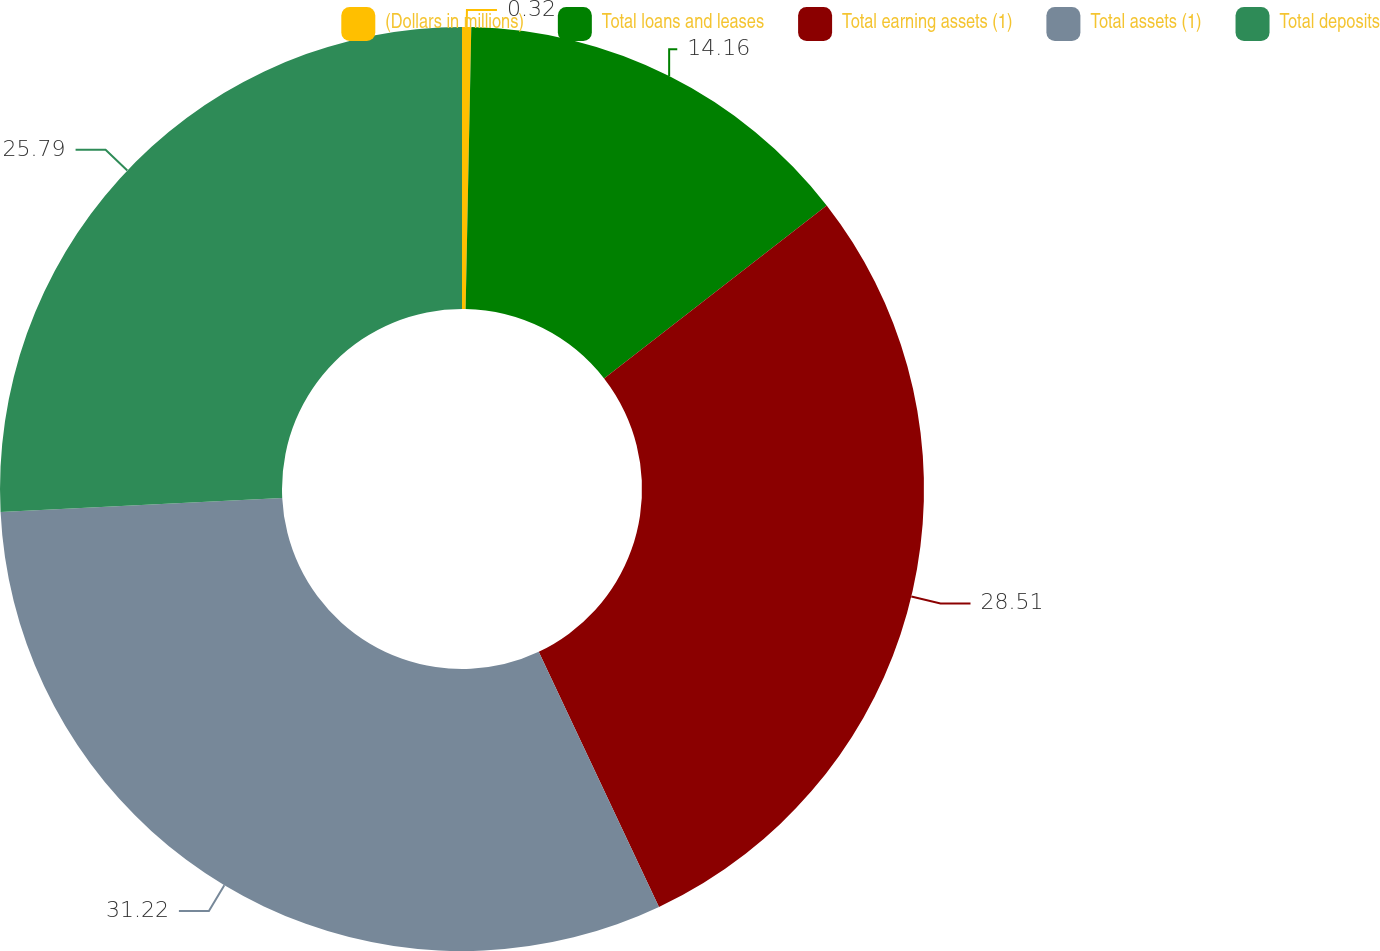Convert chart. <chart><loc_0><loc_0><loc_500><loc_500><pie_chart><fcel>(Dollars in millions)<fcel>Total loans and leases<fcel>Total earning assets (1)<fcel>Total assets (1)<fcel>Total deposits<nl><fcel>0.32%<fcel>14.16%<fcel>28.51%<fcel>31.22%<fcel>25.79%<nl></chart> 